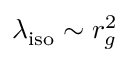Convert formula to latex. <formula><loc_0><loc_0><loc_500><loc_500>\lambda _ { i s o } \sim r _ { g } ^ { 2 }</formula> 